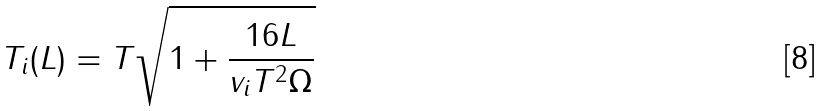<formula> <loc_0><loc_0><loc_500><loc_500>T _ { i } ( L ) = T \sqrt { 1 + \frac { 1 6 L } { v _ { i } T ^ { 2 } \Omega } }</formula> 